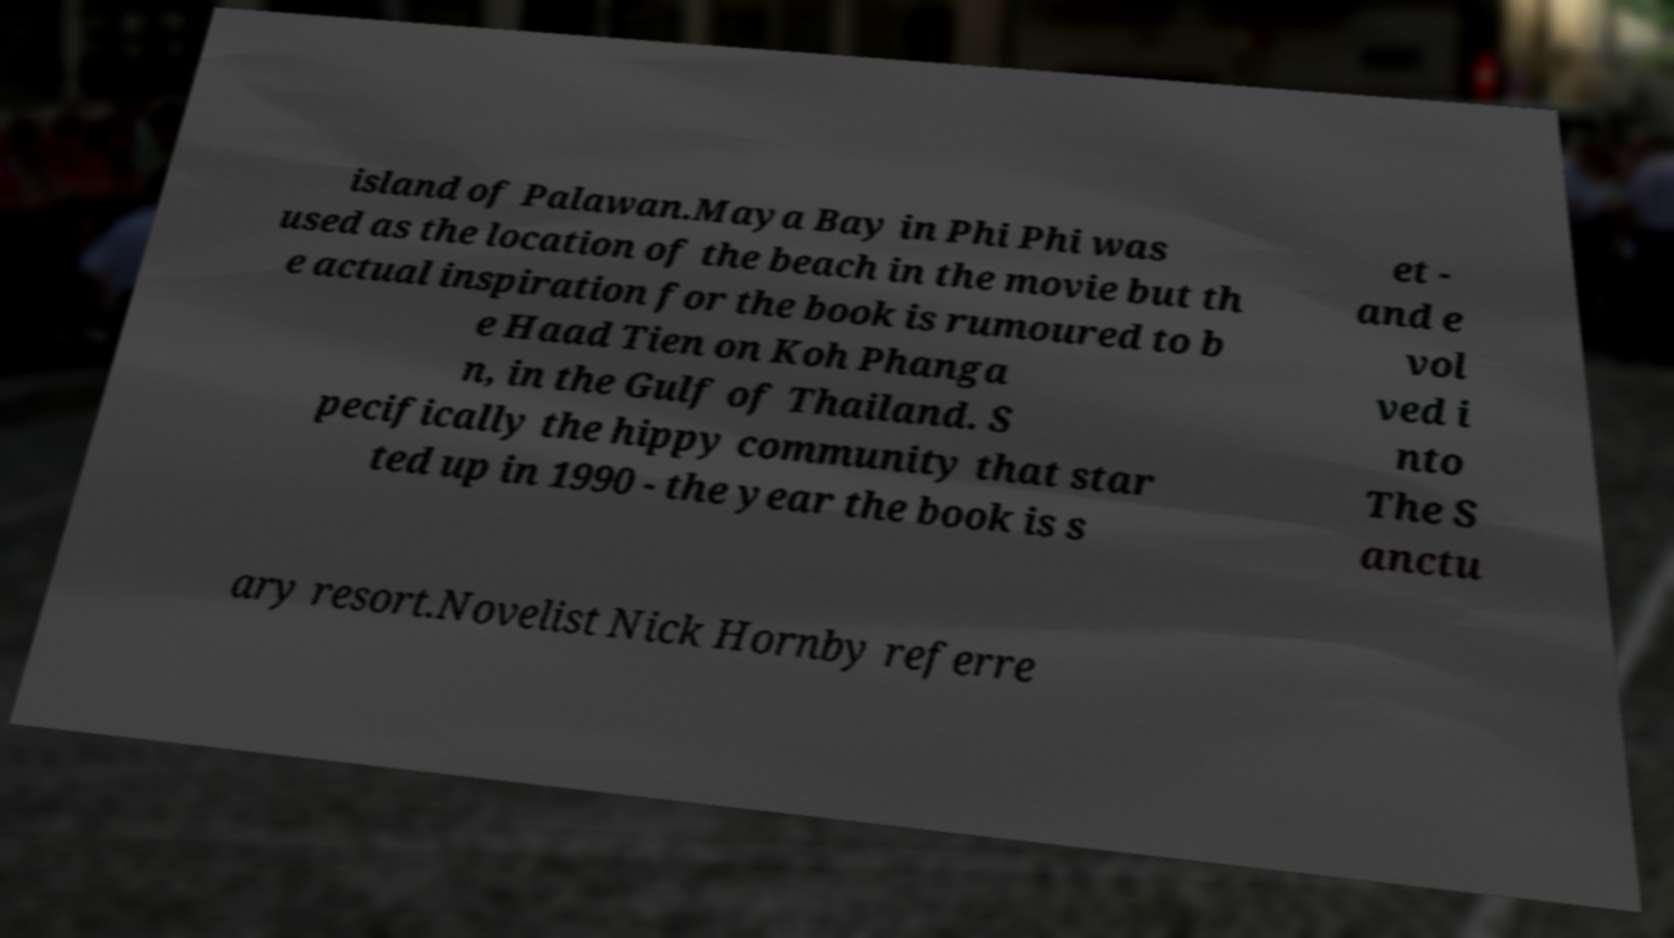Can you accurately transcribe the text from the provided image for me? island of Palawan.Maya Bay in Phi Phi was used as the location of the beach in the movie but th e actual inspiration for the book is rumoured to b e Haad Tien on Koh Phanga n, in the Gulf of Thailand. S pecifically the hippy community that star ted up in 1990 - the year the book is s et - and e vol ved i nto The S anctu ary resort.Novelist Nick Hornby referre 